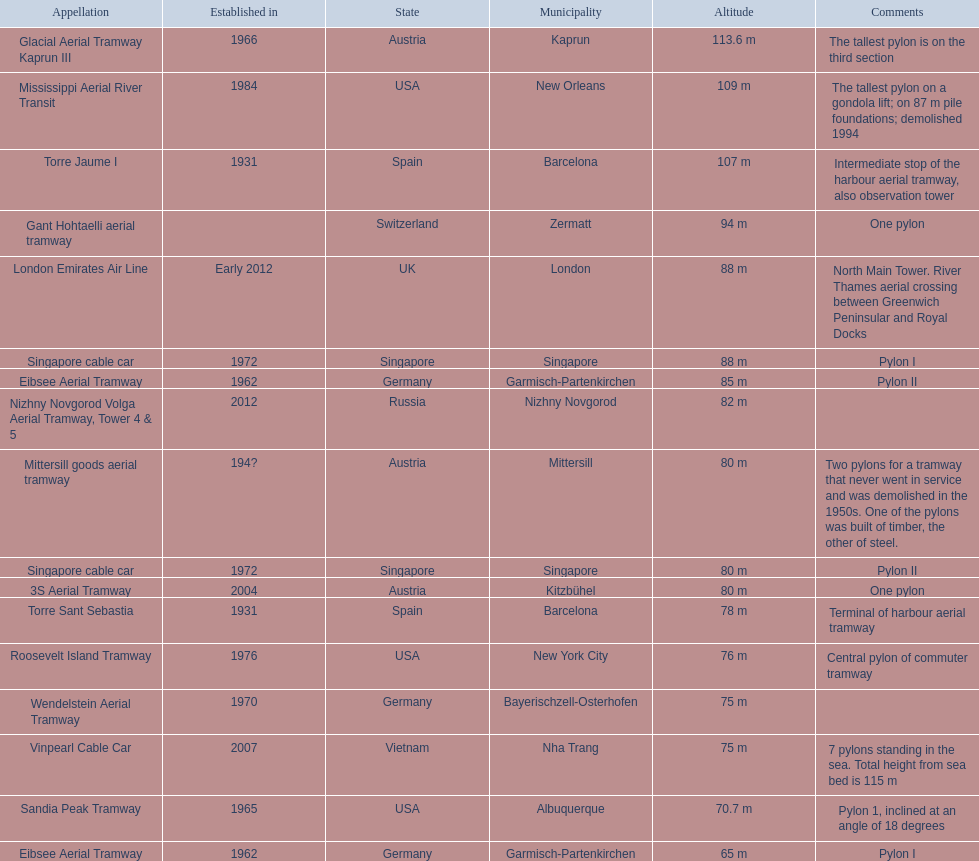Which pylon has the most remarks about it? Mittersill goods aerial tramway. 